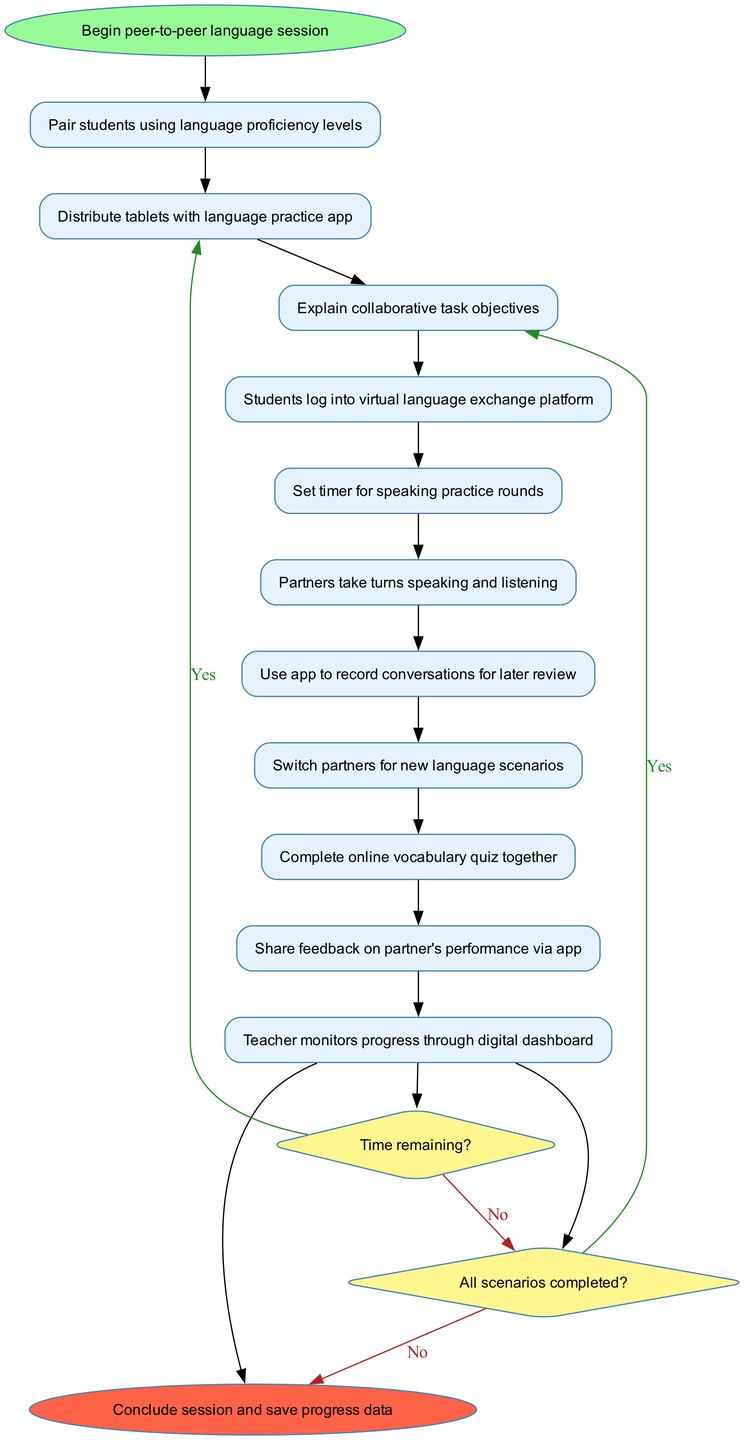What is the first activity in the session? The first activity is specified as "Pair students using language proficiency levels," which is connected to the start node.
Answer: Pair students using language proficiency levels How many activities are in the diagram? There are a total of 10 activities listed in the 'activities' section of the data provided.
Answer: 10 What decision follows the last activity? The last activity leads directly to the decision "Time remaining?" Check at the end of the activities before proceeding to the conclusion.
Answer: Time remaining? What is the condition for moving to the feedback phase? The condition "All scenarios completed?" leads to the feedback phase if answered with a "yes". This indicates that all scenarios must be finished before feedback is provided.
Answer: All scenarios completed? If there is time remaining, what happens next? If there is time remaining ("yes"), the next action according to the flow is to "Continue with next activity," meaning they will proceed with the sequence as planned.
Answer: Continue with next activity What color represents the end node in the diagram? The end node is colored with a fillcolor of '#FF6347', which is a shade of red, distinguishing it from other nodes in the diagram.
Answer: Red What happens when the answer to "All scenarios completed?" is no? If the answer is "no," then the flow indicates that they will "Switch partners and continue," suggesting ongoing participation until all scenarios are completed.
Answer: Switch partners and continue How are activities related in the sequence? The activities are sequentially connected with directed edges, indicating that each activity follows the previous one in a specific order until the last activity is reached.
Answer: Sequentially connected What is the purpose of the digital dashboard in the activities? The teacher monitors progress through the digital dashboard, allowing for oversight on students’ engagement and performance during the session.
Answer: Monitor progress What is the final action taken at the end of the session? The final action at the end of the session is to "Conclude session and save progress data," ensuring that all practices and records are stored for future reference.
Answer: Conclude session and save progress data 